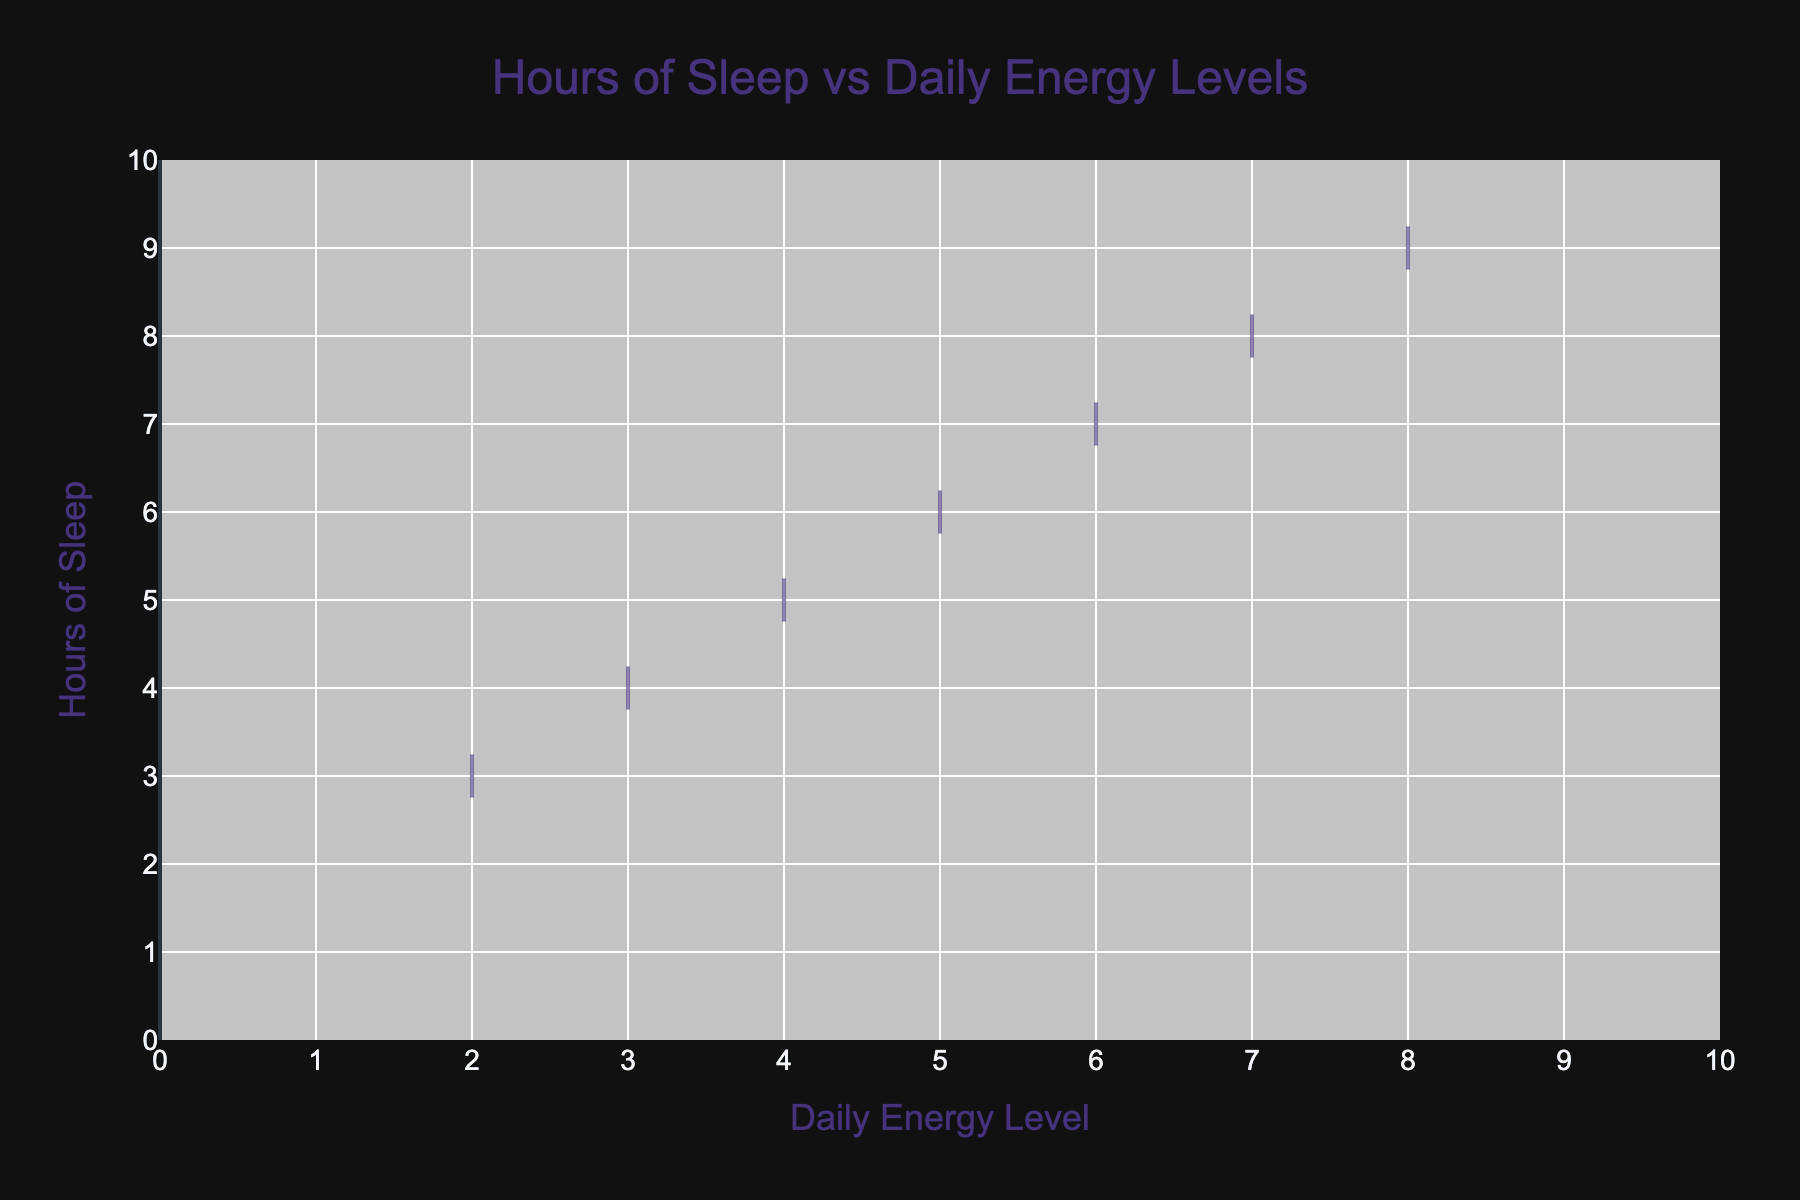What is the title of the chart? The title of the chart is usually displayed prominently at the top. It is often a concise summary of what the chart represents.
Answer: Hours of Sleep vs Daily Energy Levels What is the range of the x-axis? The x-axis represents the 'Daily Energy Level' and its range is indicated by the numbers along the axis.
Answer: 0 to 10 What color is used to fill the violin plot? The fill color of the violin plot is often described in the legend or can be observed directly from the plot.
Answer: Light teal How many data points represent a daily energy level of 5? Identify the cluster of data points at the x-axis value of 5 and count them.
Answer: 4 Does the chart show if more sleep generally correlates with higher energy levels? Evaluate the overall trend of the violin plot. If the plot indicates higher energy levels associated with more sleep hours, it shows a positive correlation.
Answer: Yes What is the most common number of hours of sleep for a daily energy level of 6? Observe the distribution of the Y values where the X value is 6. The mode is the peak of the distribution.
Answer: 6 hours How many hours of sleep does the least energetic student get? Look for the lowest 'Daily Energy Level' and check the corresponding 'Hours of Sleep'.
Answer: 3 hours Compare the average number of sleep hours among students who report an energy level of 3 and those reporting an energy level of 7. Calculate the average hours of sleep for each energy level group by summing the hours of sleep and dividing by the count of data points for each energy level.
Answer: 3.5 hours for 3, 7 hours for 7 Is there a more concentrated distribution of sleep hours for higher or lower energy levels? Analyze the spread of the violin plot's thickness. A narrower shape indicates a more concentrated distribution.
Answer: Higher energy levels What is the median daily energy level for students who sleep for 6 hours? Identify the middle value of the 'Daily Energy Level' for students with 6 hours of sleep.
Answer: 5 